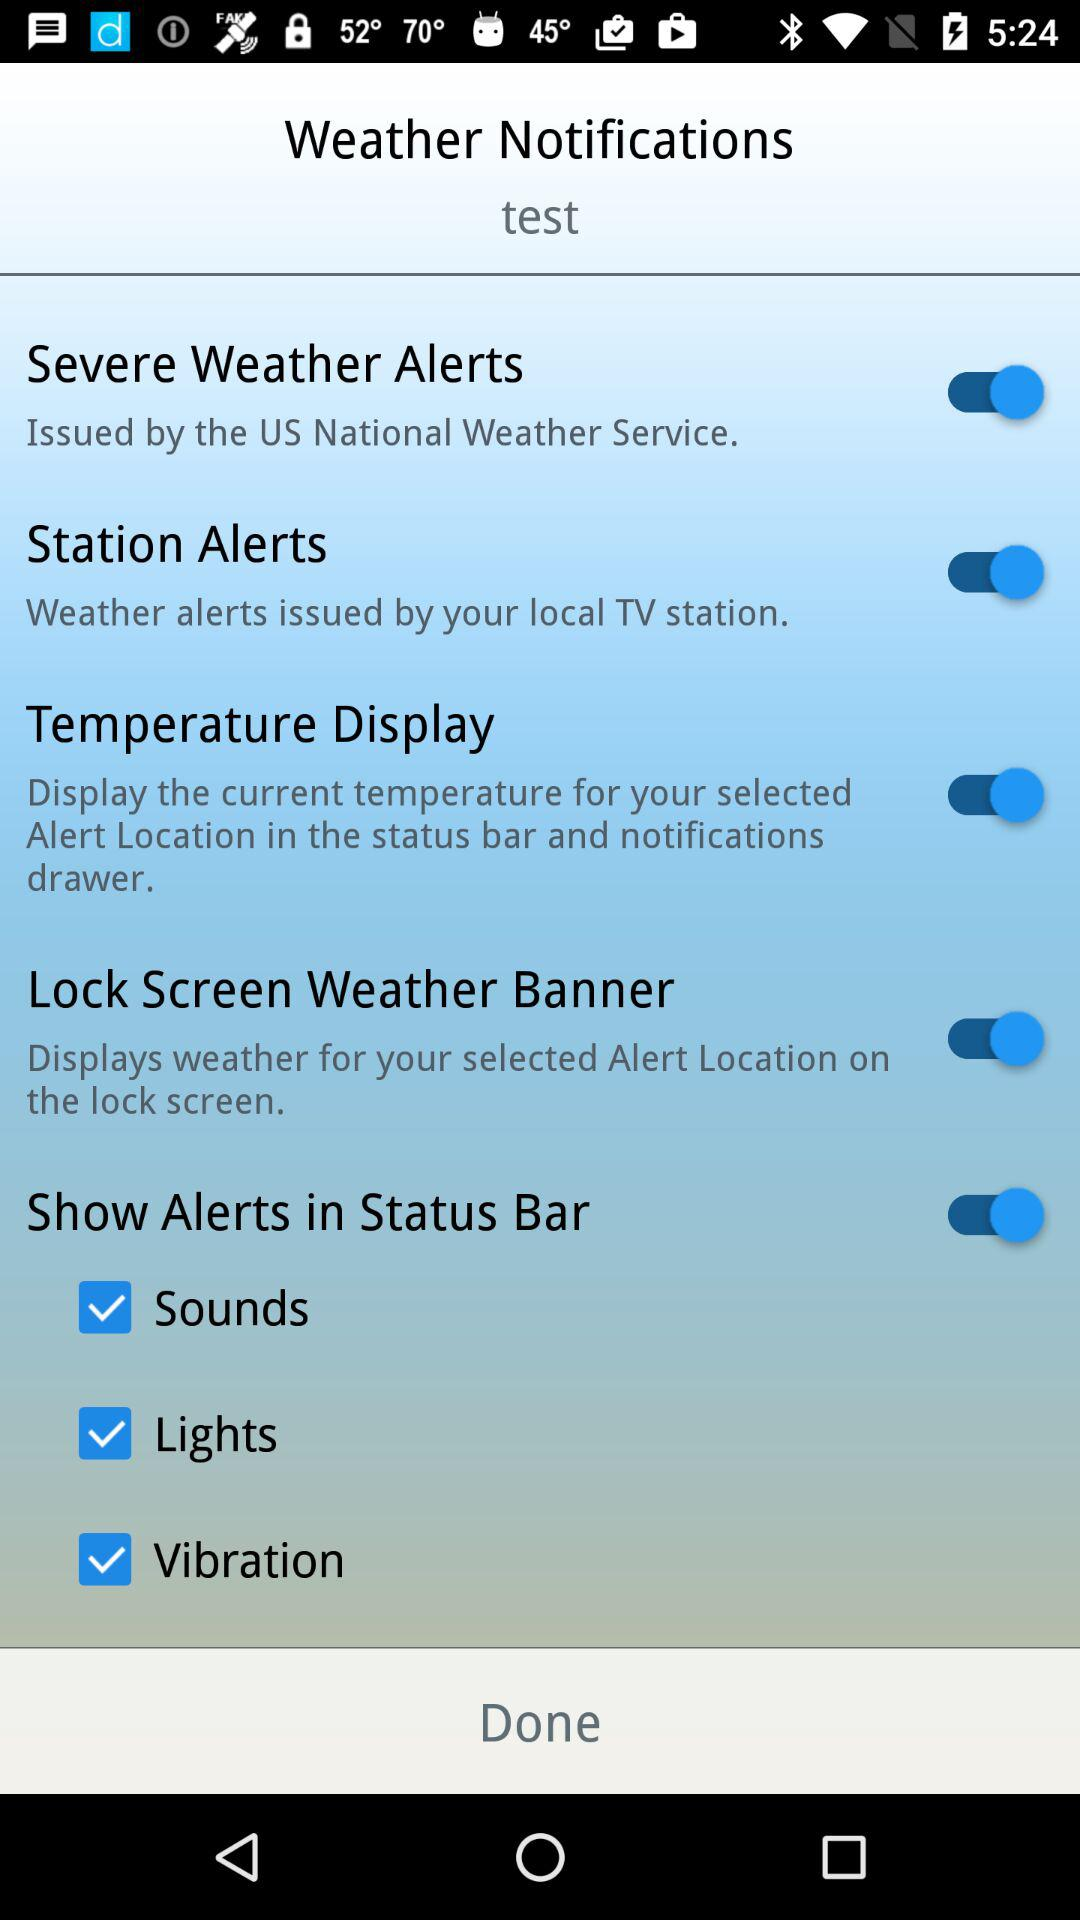What's the status of "Severe Weather Alerts"? The status is "on". 